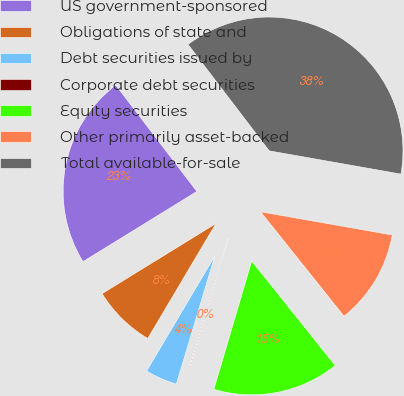Convert chart to OTSL. <chart><loc_0><loc_0><loc_500><loc_500><pie_chart><fcel>US government-sponsored<fcel>Obligations of state and<fcel>Debt securities issued by<fcel>Corporate debt securities<fcel>Equity securities<fcel>Other primarily asset-backed<fcel>Total available-for-sale<nl><fcel>23.42%<fcel>7.69%<fcel>3.88%<fcel>0.07%<fcel>15.3%<fcel>11.49%<fcel>38.15%<nl></chart> 